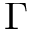Convert formula to latex. <formula><loc_0><loc_0><loc_500><loc_500>\Gamma</formula> 